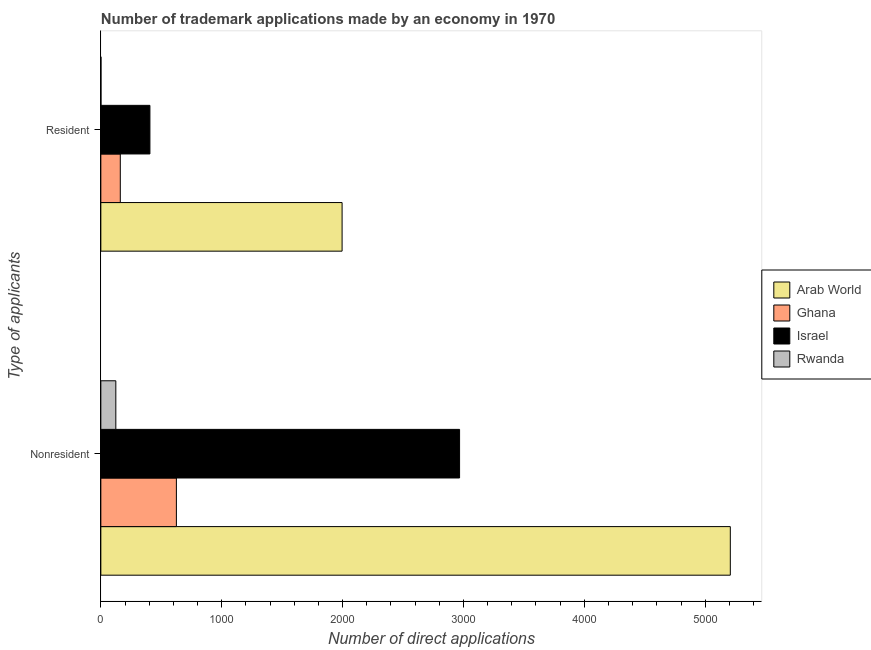Are the number of bars on each tick of the Y-axis equal?
Provide a short and direct response. Yes. What is the label of the 2nd group of bars from the top?
Your answer should be compact. Nonresident. What is the number of trademark applications made by residents in Ghana?
Offer a terse response. 161. Across all countries, what is the maximum number of trademark applications made by non residents?
Provide a succinct answer. 5208. Across all countries, what is the minimum number of trademark applications made by non residents?
Your answer should be compact. 124. In which country was the number of trademark applications made by residents maximum?
Provide a short and direct response. Arab World. In which country was the number of trademark applications made by residents minimum?
Offer a terse response. Rwanda. What is the total number of trademark applications made by non residents in the graph?
Your answer should be very brief. 8925. What is the difference between the number of trademark applications made by non residents in Rwanda and that in Ghana?
Your response must be concise. -501. What is the difference between the number of trademark applications made by residents in Israel and the number of trademark applications made by non residents in Rwanda?
Keep it short and to the point. 282. What is the average number of trademark applications made by residents per country?
Your response must be concise. 641. What is the difference between the number of trademark applications made by residents and number of trademark applications made by non residents in Israel?
Provide a short and direct response. -2562. In how many countries, is the number of trademark applications made by non residents greater than 4600 ?
Ensure brevity in your answer.  1. What is the ratio of the number of trademark applications made by non residents in Israel to that in Arab World?
Offer a very short reply. 0.57. What does the 4th bar from the top in Nonresident represents?
Keep it short and to the point. Arab World. What does the 2nd bar from the bottom in Nonresident represents?
Make the answer very short. Ghana. How many bars are there?
Offer a terse response. 8. Are all the bars in the graph horizontal?
Your response must be concise. Yes. How many countries are there in the graph?
Offer a terse response. 4. What is the difference between two consecutive major ticks on the X-axis?
Give a very brief answer. 1000. Does the graph contain grids?
Make the answer very short. No. Where does the legend appear in the graph?
Your answer should be compact. Center right. What is the title of the graph?
Ensure brevity in your answer.  Number of trademark applications made by an economy in 1970. Does "Senegal" appear as one of the legend labels in the graph?
Give a very brief answer. No. What is the label or title of the X-axis?
Keep it short and to the point. Number of direct applications. What is the label or title of the Y-axis?
Give a very brief answer. Type of applicants. What is the Number of direct applications of Arab World in Nonresident?
Offer a very short reply. 5208. What is the Number of direct applications in Ghana in Nonresident?
Your answer should be compact. 625. What is the Number of direct applications in Israel in Nonresident?
Provide a short and direct response. 2968. What is the Number of direct applications in Rwanda in Nonresident?
Your response must be concise. 124. What is the Number of direct applications in Arab World in Resident?
Keep it short and to the point. 1996. What is the Number of direct applications in Ghana in Resident?
Your answer should be very brief. 161. What is the Number of direct applications in Israel in Resident?
Your answer should be very brief. 406. Across all Type of applicants, what is the maximum Number of direct applications in Arab World?
Provide a short and direct response. 5208. Across all Type of applicants, what is the maximum Number of direct applications in Ghana?
Your response must be concise. 625. Across all Type of applicants, what is the maximum Number of direct applications of Israel?
Your answer should be compact. 2968. Across all Type of applicants, what is the maximum Number of direct applications in Rwanda?
Make the answer very short. 124. Across all Type of applicants, what is the minimum Number of direct applications in Arab World?
Ensure brevity in your answer.  1996. Across all Type of applicants, what is the minimum Number of direct applications of Ghana?
Make the answer very short. 161. Across all Type of applicants, what is the minimum Number of direct applications of Israel?
Make the answer very short. 406. What is the total Number of direct applications of Arab World in the graph?
Your answer should be compact. 7204. What is the total Number of direct applications in Ghana in the graph?
Your answer should be very brief. 786. What is the total Number of direct applications of Israel in the graph?
Make the answer very short. 3374. What is the total Number of direct applications in Rwanda in the graph?
Your answer should be compact. 125. What is the difference between the Number of direct applications in Arab World in Nonresident and that in Resident?
Your answer should be very brief. 3212. What is the difference between the Number of direct applications of Ghana in Nonresident and that in Resident?
Your answer should be very brief. 464. What is the difference between the Number of direct applications in Israel in Nonresident and that in Resident?
Offer a terse response. 2562. What is the difference between the Number of direct applications in Rwanda in Nonresident and that in Resident?
Offer a terse response. 123. What is the difference between the Number of direct applications of Arab World in Nonresident and the Number of direct applications of Ghana in Resident?
Your response must be concise. 5047. What is the difference between the Number of direct applications of Arab World in Nonresident and the Number of direct applications of Israel in Resident?
Your response must be concise. 4802. What is the difference between the Number of direct applications in Arab World in Nonresident and the Number of direct applications in Rwanda in Resident?
Give a very brief answer. 5207. What is the difference between the Number of direct applications in Ghana in Nonresident and the Number of direct applications in Israel in Resident?
Provide a succinct answer. 219. What is the difference between the Number of direct applications of Ghana in Nonresident and the Number of direct applications of Rwanda in Resident?
Provide a succinct answer. 624. What is the difference between the Number of direct applications in Israel in Nonresident and the Number of direct applications in Rwanda in Resident?
Your answer should be compact. 2967. What is the average Number of direct applications of Arab World per Type of applicants?
Your response must be concise. 3602. What is the average Number of direct applications of Ghana per Type of applicants?
Your response must be concise. 393. What is the average Number of direct applications of Israel per Type of applicants?
Keep it short and to the point. 1687. What is the average Number of direct applications of Rwanda per Type of applicants?
Keep it short and to the point. 62.5. What is the difference between the Number of direct applications in Arab World and Number of direct applications in Ghana in Nonresident?
Provide a succinct answer. 4583. What is the difference between the Number of direct applications of Arab World and Number of direct applications of Israel in Nonresident?
Your answer should be compact. 2240. What is the difference between the Number of direct applications in Arab World and Number of direct applications in Rwanda in Nonresident?
Offer a terse response. 5084. What is the difference between the Number of direct applications in Ghana and Number of direct applications in Israel in Nonresident?
Your response must be concise. -2343. What is the difference between the Number of direct applications of Ghana and Number of direct applications of Rwanda in Nonresident?
Your answer should be very brief. 501. What is the difference between the Number of direct applications of Israel and Number of direct applications of Rwanda in Nonresident?
Provide a short and direct response. 2844. What is the difference between the Number of direct applications in Arab World and Number of direct applications in Ghana in Resident?
Give a very brief answer. 1835. What is the difference between the Number of direct applications of Arab World and Number of direct applications of Israel in Resident?
Keep it short and to the point. 1590. What is the difference between the Number of direct applications in Arab World and Number of direct applications in Rwanda in Resident?
Provide a succinct answer. 1995. What is the difference between the Number of direct applications in Ghana and Number of direct applications in Israel in Resident?
Ensure brevity in your answer.  -245. What is the difference between the Number of direct applications of Ghana and Number of direct applications of Rwanda in Resident?
Your answer should be very brief. 160. What is the difference between the Number of direct applications in Israel and Number of direct applications in Rwanda in Resident?
Offer a very short reply. 405. What is the ratio of the Number of direct applications of Arab World in Nonresident to that in Resident?
Keep it short and to the point. 2.61. What is the ratio of the Number of direct applications in Ghana in Nonresident to that in Resident?
Keep it short and to the point. 3.88. What is the ratio of the Number of direct applications of Israel in Nonresident to that in Resident?
Your answer should be very brief. 7.31. What is the ratio of the Number of direct applications of Rwanda in Nonresident to that in Resident?
Keep it short and to the point. 124. What is the difference between the highest and the second highest Number of direct applications of Arab World?
Provide a short and direct response. 3212. What is the difference between the highest and the second highest Number of direct applications in Ghana?
Your answer should be compact. 464. What is the difference between the highest and the second highest Number of direct applications in Israel?
Your answer should be very brief. 2562. What is the difference between the highest and the second highest Number of direct applications of Rwanda?
Your response must be concise. 123. What is the difference between the highest and the lowest Number of direct applications of Arab World?
Your answer should be very brief. 3212. What is the difference between the highest and the lowest Number of direct applications in Ghana?
Give a very brief answer. 464. What is the difference between the highest and the lowest Number of direct applications in Israel?
Your response must be concise. 2562. What is the difference between the highest and the lowest Number of direct applications of Rwanda?
Your answer should be compact. 123. 